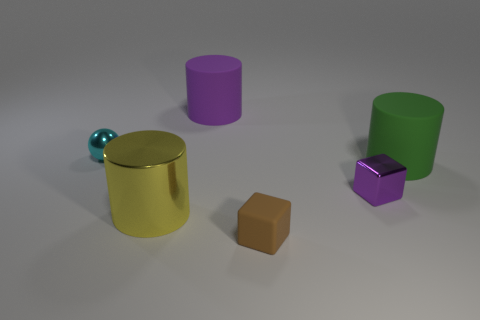Add 3 matte cylinders. How many objects exist? 9 Subtract all balls. How many objects are left? 5 Add 2 large metal cylinders. How many large metal cylinders exist? 3 Subtract 0 purple spheres. How many objects are left? 6 Subtract all large purple cylinders. Subtract all big purple rubber cylinders. How many objects are left? 4 Add 4 small rubber things. How many small rubber things are left? 5 